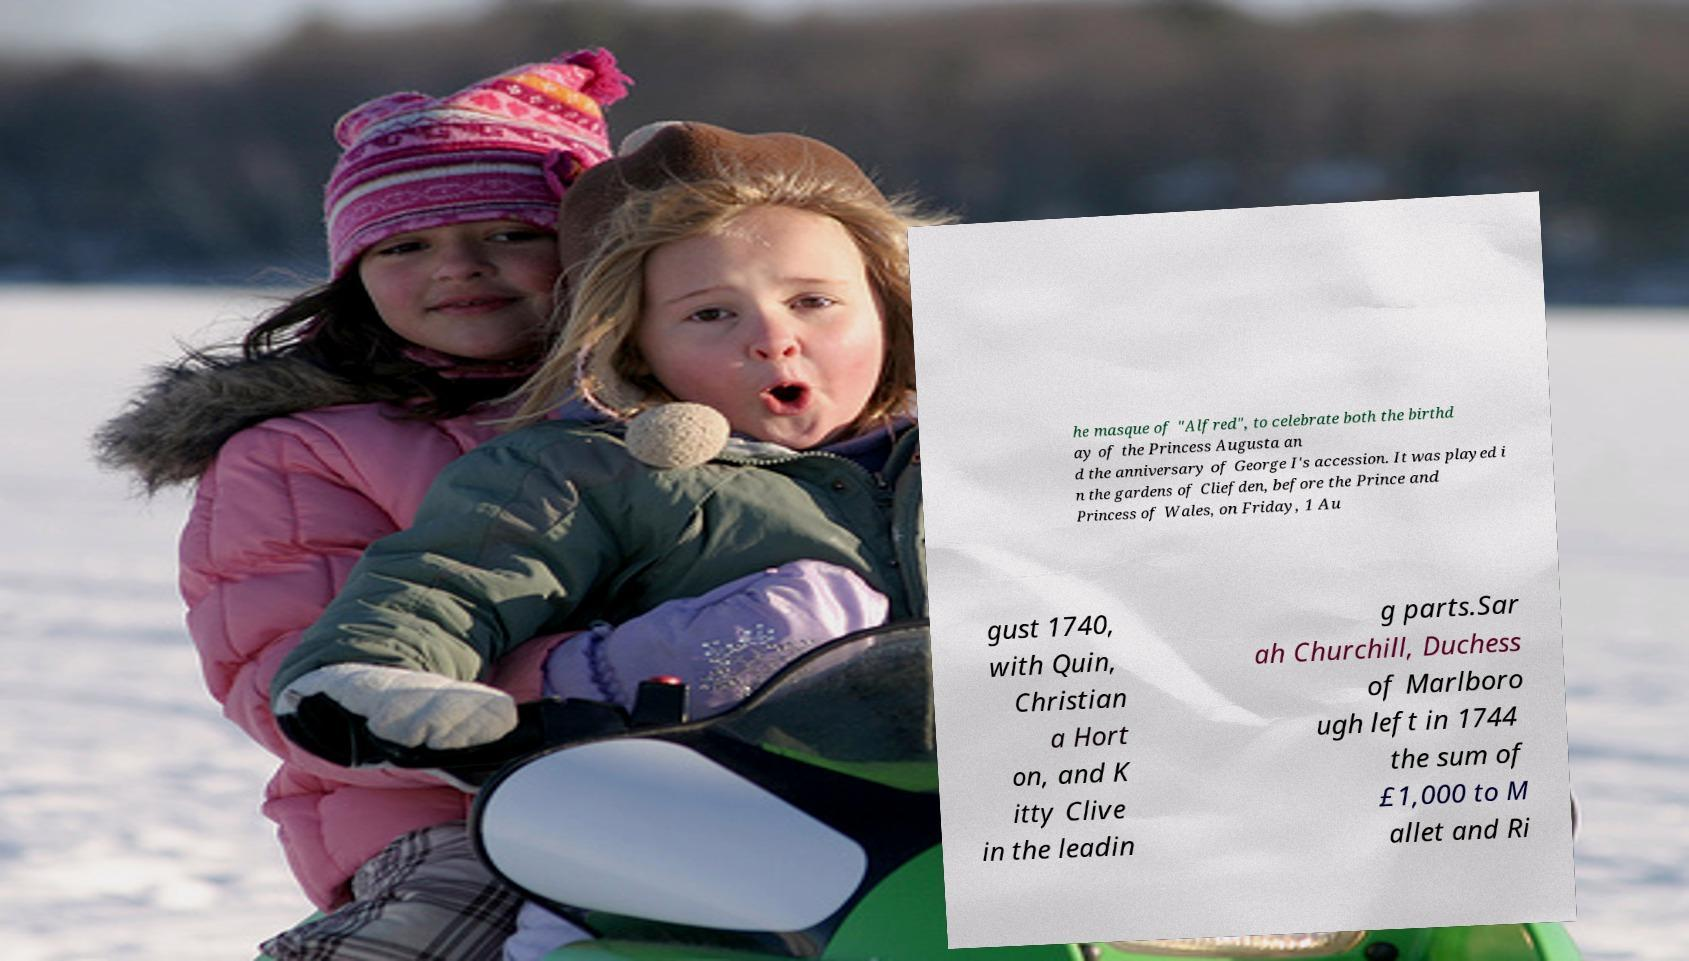What messages or text are displayed in this image? I need them in a readable, typed format. he masque of "Alfred", to celebrate both the birthd ay of the Princess Augusta an d the anniversary of George I's accession. It was played i n the gardens of Cliefden, before the Prince and Princess of Wales, on Friday, 1 Au gust 1740, with Quin, Christian a Hort on, and K itty Clive in the leadin g parts.Sar ah Churchill, Duchess of Marlboro ugh left in 1744 the sum of £1,000 to M allet and Ri 